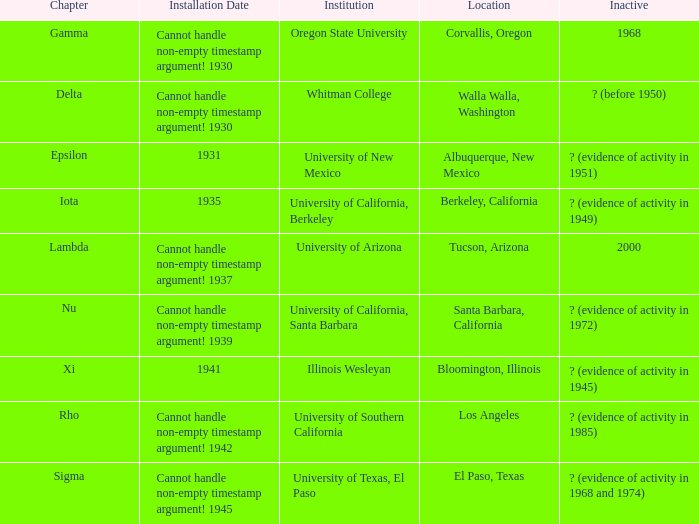What is the chapter for Illinois Wesleyan?  Xi. 